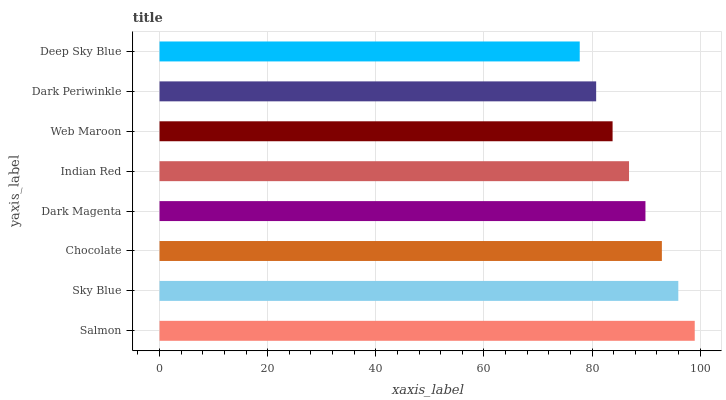Is Deep Sky Blue the minimum?
Answer yes or no. Yes. Is Salmon the maximum?
Answer yes or no. Yes. Is Sky Blue the minimum?
Answer yes or no. No. Is Sky Blue the maximum?
Answer yes or no. No. Is Salmon greater than Sky Blue?
Answer yes or no. Yes. Is Sky Blue less than Salmon?
Answer yes or no. Yes. Is Sky Blue greater than Salmon?
Answer yes or no. No. Is Salmon less than Sky Blue?
Answer yes or no. No. Is Dark Magenta the high median?
Answer yes or no. Yes. Is Indian Red the low median?
Answer yes or no. Yes. Is Dark Periwinkle the high median?
Answer yes or no. No. Is Sky Blue the low median?
Answer yes or no. No. 